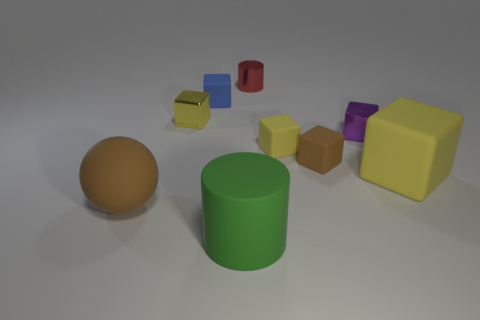How many yellow cubes must be subtracted to get 1 yellow cubes? 2 Subtract all purple spheres. How many yellow cubes are left? 3 Subtract 3 blocks. How many blocks are left? 3 Subtract all brown blocks. How many blocks are left? 5 Subtract all blue matte blocks. How many blocks are left? 5 Add 1 tiny brown metal blocks. How many objects exist? 10 Subtract all purple blocks. Subtract all gray cylinders. How many blocks are left? 5 Subtract all balls. How many objects are left? 8 Add 2 blue objects. How many blue objects are left? 3 Add 7 green rubber things. How many green rubber things exist? 8 